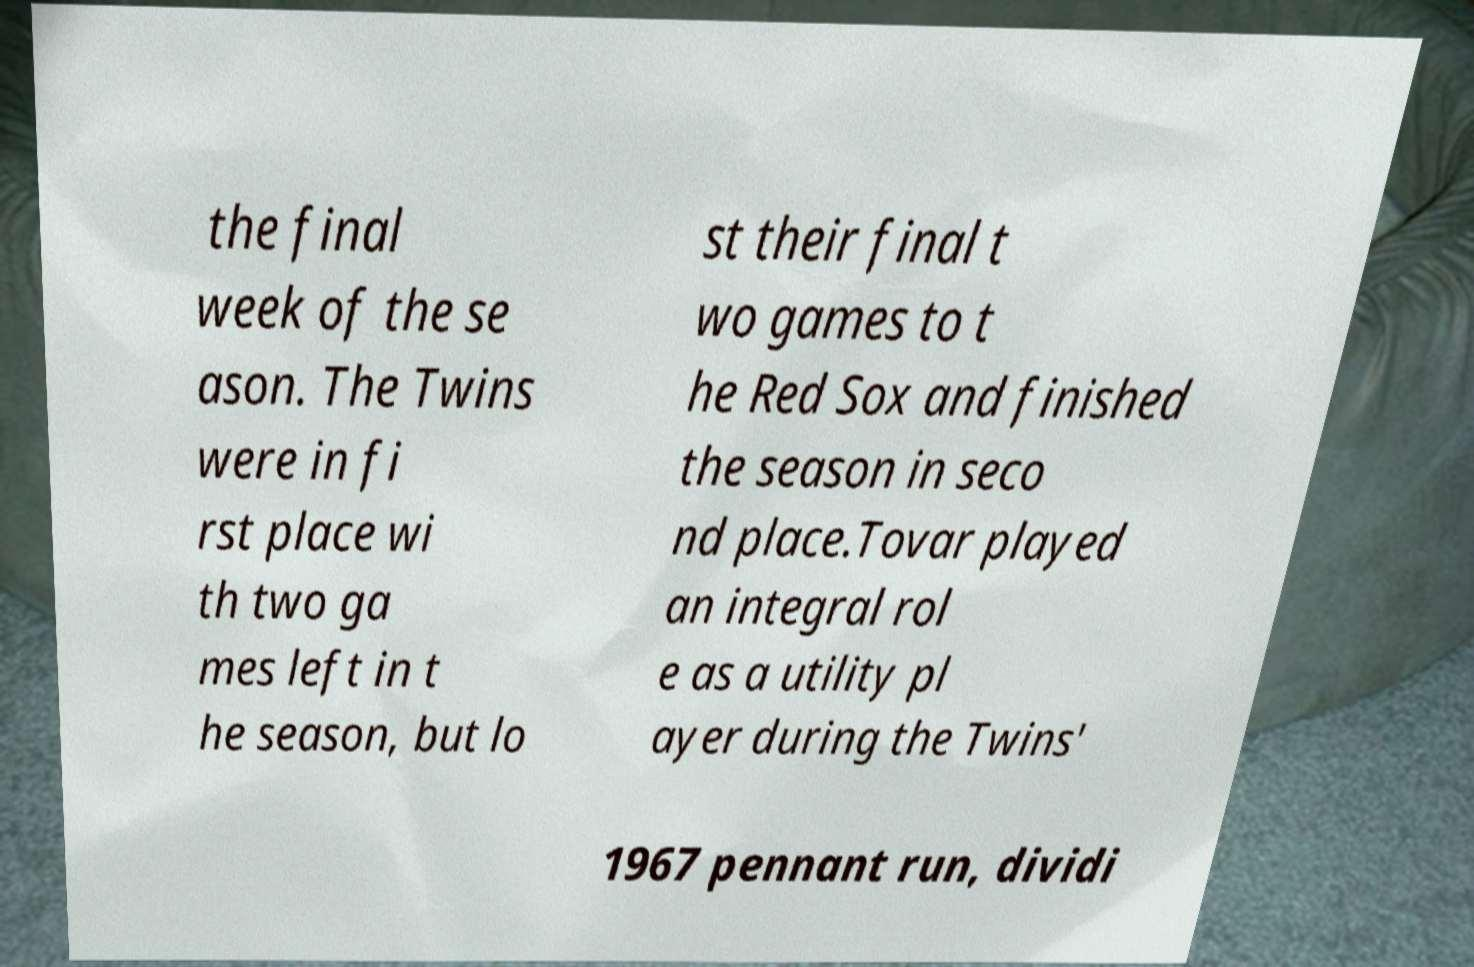What messages or text are displayed in this image? I need them in a readable, typed format. the final week of the se ason. The Twins were in fi rst place wi th two ga mes left in t he season, but lo st their final t wo games to t he Red Sox and finished the season in seco nd place.Tovar played an integral rol e as a utility pl ayer during the Twins' 1967 pennant run, dividi 